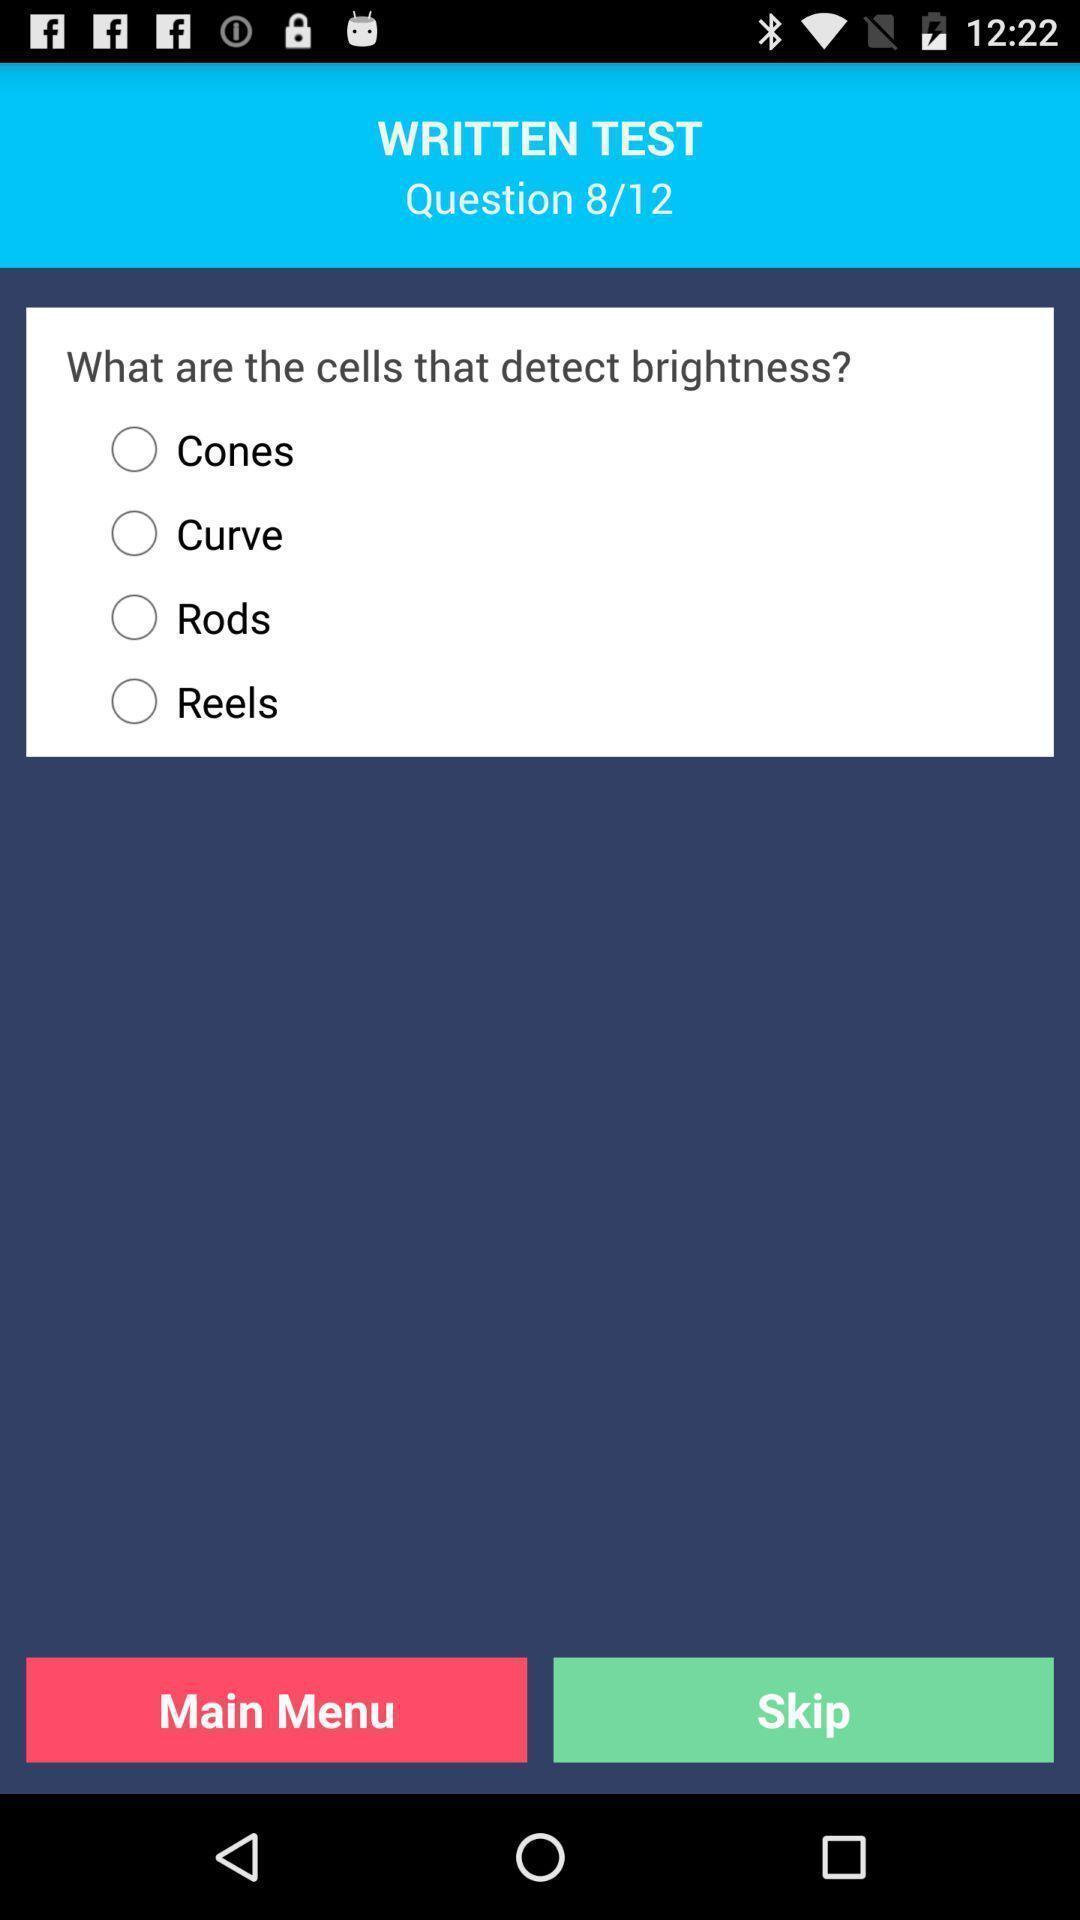Explain the elements present in this screenshot. Screen shows written test page in eye check up application. 